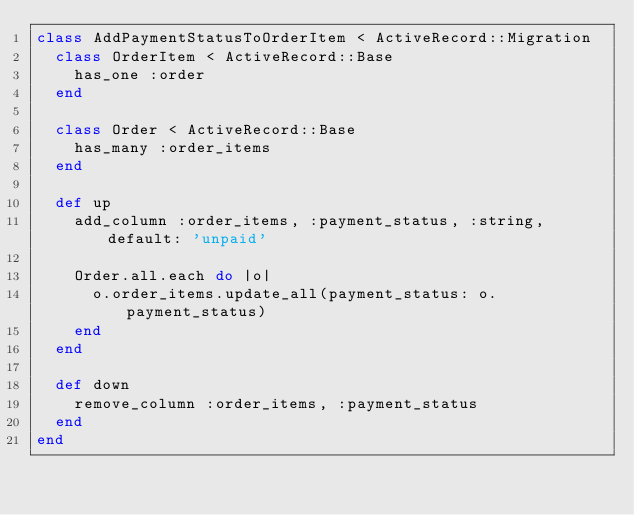Convert code to text. <code><loc_0><loc_0><loc_500><loc_500><_Ruby_>class AddPaymentStatusToOrderItem < ActiveRecord::Migration
  class OrderItem < ActiveRecord::Base
    has_one :order
  end

  class Order < ActiveRecord::Base
    has_many :order_items
  end

  def up
    add_column :order_items, :payment_status, :string, default: 'unpaid'

    Order.all.each do |o|
      o.order_items.update_all(payment_status: o.payment_status)
    end
  end

  def down
    remove_column :order_items, :payment_status
  end
end
</code> 